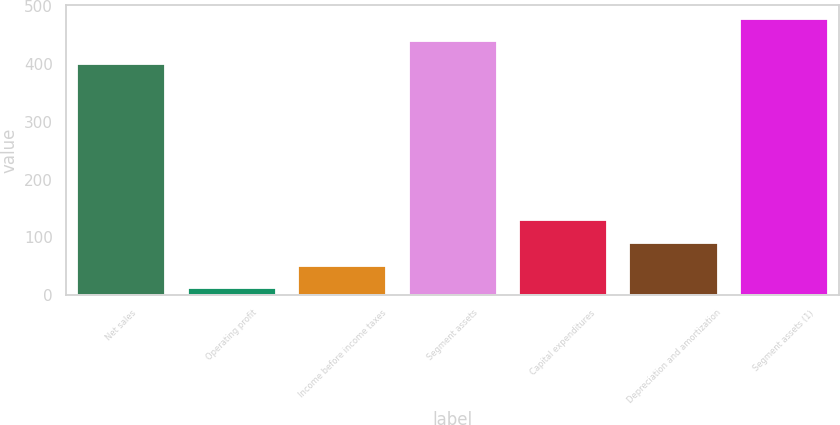Convert chart to OTSL. <chart><loc_0><loc_0><loc_500><loc_500><bar_chart><fcel>Net sales<fcel>Operating profit<fcel>Income before income taxes<fcel>Segment assets<fcel>Capital expenditures<fcel>Depreciation and amortization<fcel>Segment assets (1)<nl><fcel>400.2<fcel>12<fcel>51.31<fcel>439.51<fcel>129.93<fcel>90.62<fcel>478.82<nl></chart> 